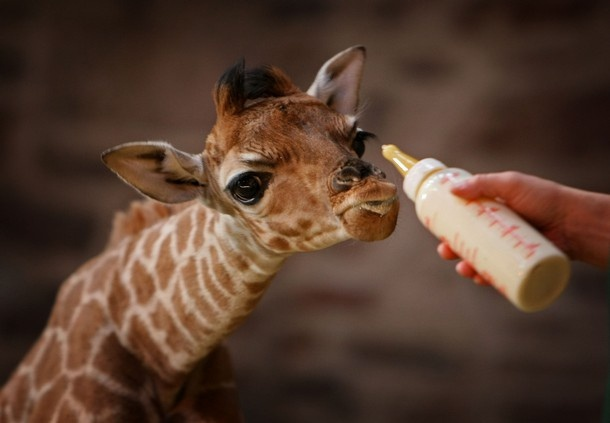Describe the objects in this image and their specific colors. I can see giraffe in black, gray, and maroon tones, bottle in black, tan, maroon, and lightgray tones, and people in black, maroon, and brown tones in this image. 